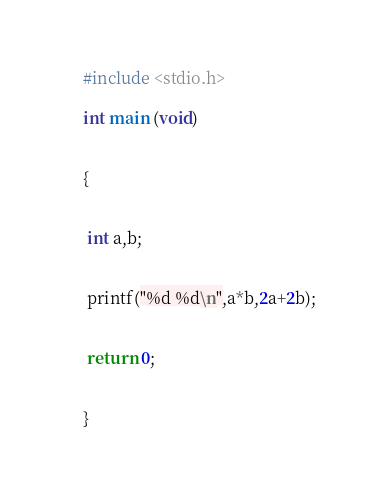Convert code to text. <code><loc_0><loc_0><loc_500><loc_500><_C_>#include <stdio.h>

int main (void)


{


 int a,b;


 printf("%d %d\n",a*b,2a+2b);


 return 0;


}</code> 